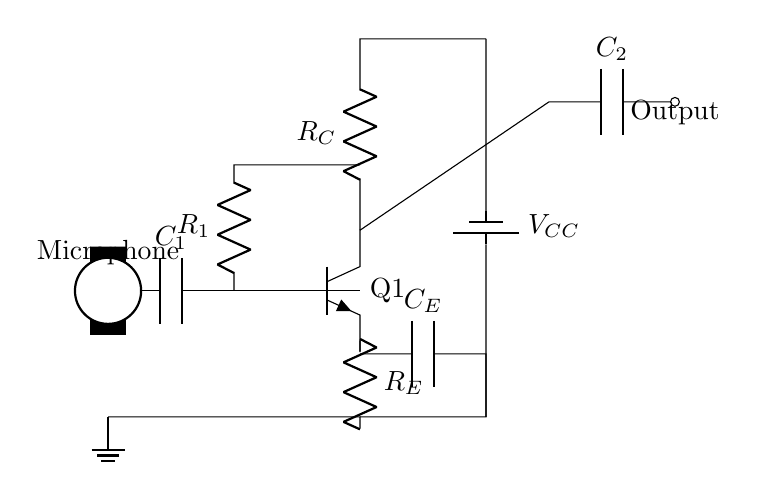What type of transistor is used in this circuit? The circuit diagram shows an npn transistor labeled Q1, indicating it is a type of transistor that amplifies current.
Answer: npn What is the function of the capacitor labeled C1? Capacitor C1 acts as a coupling capacitor, allowing AC signals from the microphone to pass while blocking DC signals, thereby preventing interference.
Answer: Coupling What is the purpose of the resistors in this amplifier circuit? In this circuit, resistor R1 is part of a voltage divider or can provide biasing for the transistor, while resistor RE stabilizes the emitter current and RC determines the output impedance of the amplifier.
Answer: Biasing and stability How is the output of the amplifier indicated in the circuit? The output is labeled as "Output" and is connected through capacitor C2, showing how the amplified signal exits the circuit.
Answer: Through C2 What component provides power to the amplifier circuit? The circuit has a battery labeled VCC that supplies necessary voltage to the amplifier circuit, allowing it to operate.
Answer: Battery Why is there a coupling capacitor (C2) at the output? Capacitor C2 allows the AC amplified signal to pass while blocking any DC component, ensuring the output is a pure audio signal for the intercom system.
Answer: To block DC 